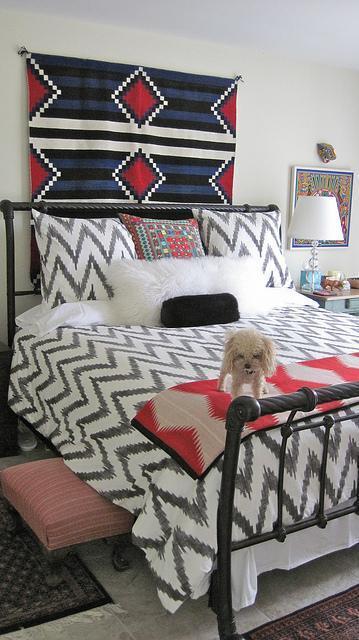How many pillows are on the bed?
Give a very brief answer. 5. 